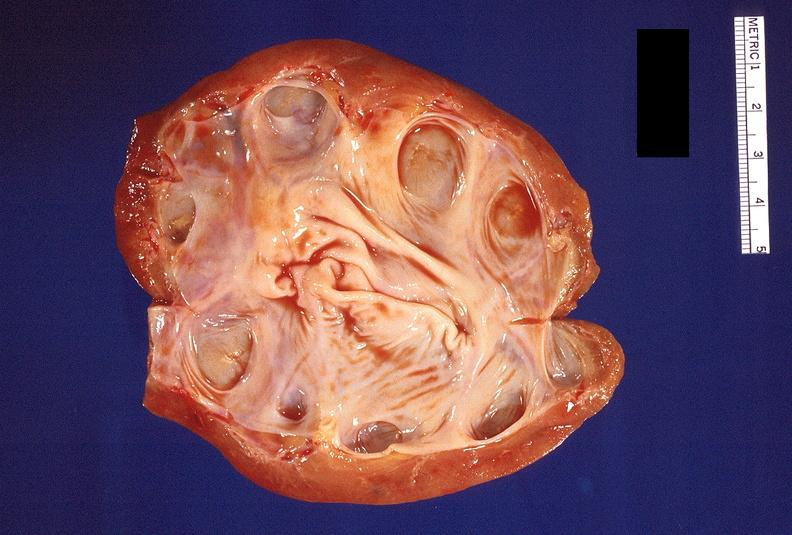does myocardium show hydronephrosis?
Answer the question using a single word or phrase. No 